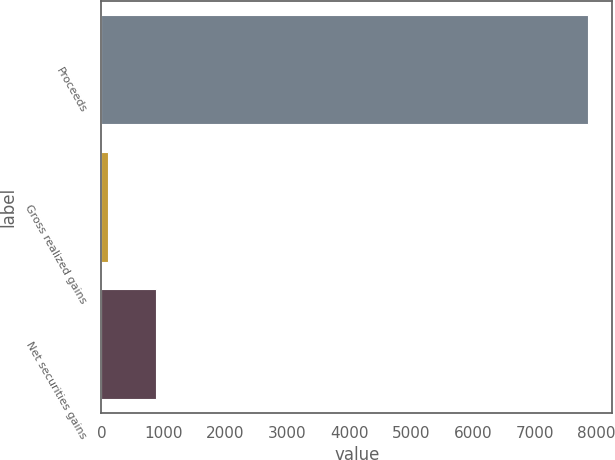<chart> <loc_0><loc_0><loc_500><loc_500><bar_chart><fcel>Proceeds<fcel>Gross realized gains<fcel>Net securities gains<nl><fcel>7859<fcel>112<fcel>886.7<nl></chart> 